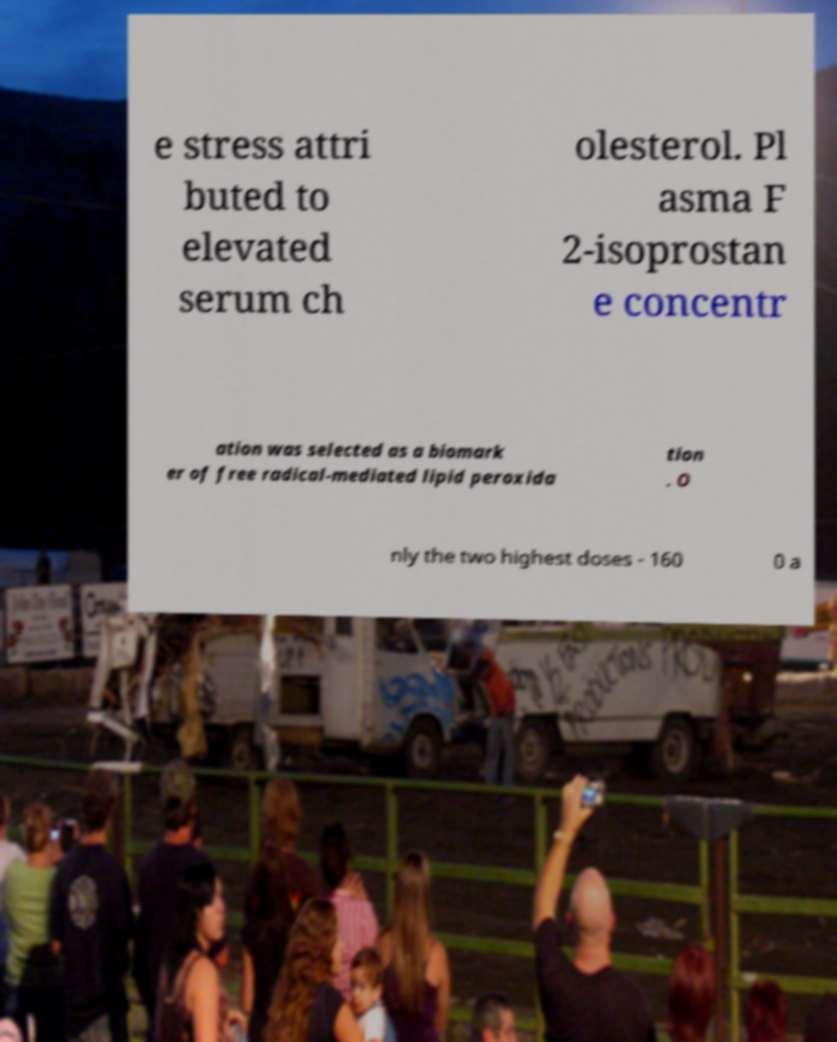Could you extract and type out the text from this image? e stress attri buted to elevated serum ch olesterol. Pl asma F 2-isoprostan e concentr ation was selected as a biomark er of free radical-mediated lipid peroxida tion . O nly the two highest doses - 160 0 a 